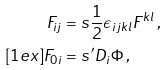<formula> <loc_0><loc_0><loc_500><loc_500>F _ { i j } & = s \frac { 1 } { 2 } \epsilon _ { i j k l } F ^ { k l } \, , \\ [ 1 e x ] F _ { 0 i } & = s ^ { \prime } D _ { i } \Phi \, ,</formula> 